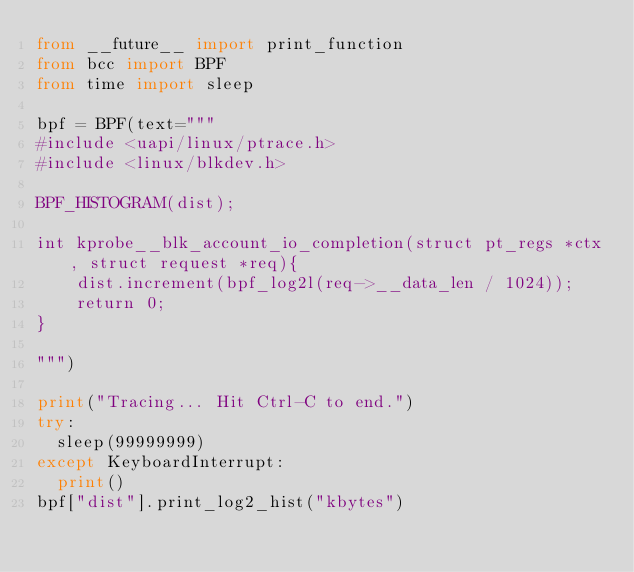<code> <loc_0><loc_0><loc_500><loc_500><_Python_>from __future__ import print_function
from bcc import BPF
from time import sleep

bpf = BPF(text="""
#include <uapi/linux/ptrace.h>
#include <linux/blkdev.h>

BPF_HISTOGRAM(dist);

int kprobe__blk_account_io_completion(struct pt_regs *ctx, struct request *req){
    dist.increment(bpf_log2l(req->__data_len / 1024));
    return 0;
}

""")

print("Tracing... Hit Ctrl-C to end.")
try:
	sleep(99999999)
except KeyboardInterrupt:
	print()
bpf["dist"].print_log2_hist("kbytes")

</code> 